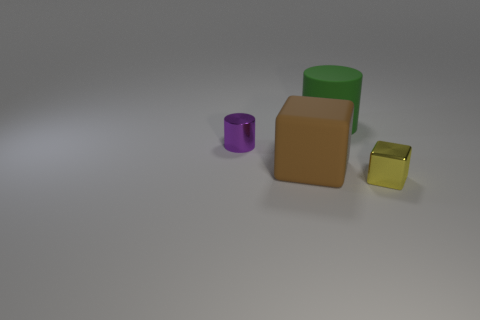Does the cube on the right side of the green matte cylinder have the same material as the purple object?
Offer a terse response. Yes. What number of other objects are the same size as the purple cylinder?
Offer a very short reply. 1. What number of small things are either red metal cylinders or green things?
Provide a succinct answer. 0. Do the metallic block and the small shiny cylinder have the same color?
Your response must be concise. No. Are there more large green rubber cylinders in front of the large brown thing than tiny metallic cylinders behind the small cylinder?
Offer a very short reply. No. Does the block on the left side of the tiny yellow shiny object have the same color as the small metallic cylinder?
Give a very brief answer. No. Are there any other things that are the same color as the metal block?
Your response must be concise. No. Are there more purple shiny things left of the big green cylinder than large brown blocks?
Offer a terse response. No. Does the purple shiny object have the same size as the shiny block?
Your response must be concise. Yes. There is another object that is the same shape as the purple thing; what is it made of?
Your response must be concise. Rubber. 